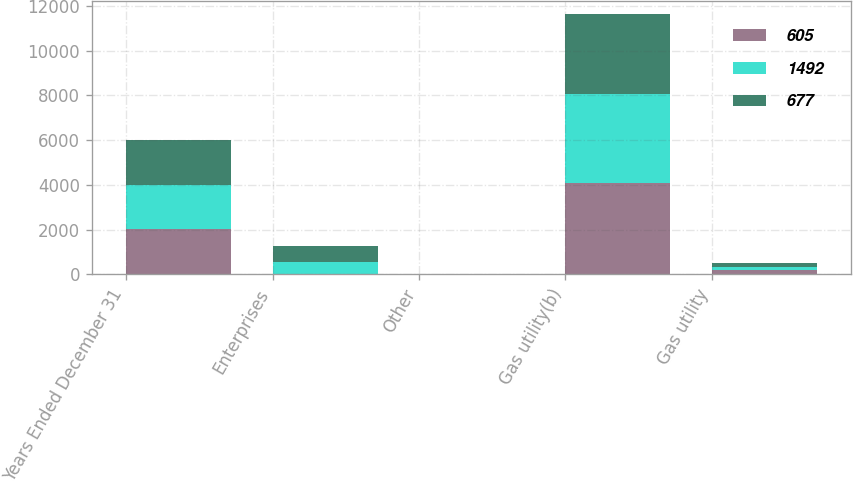<chart> <loc_0><loc_0><loc_500><loc_500><stacked_bar_chart><ecel><fcel>Years Ended December 31<fcel>Enterprises<fcel>Other<fcel>Gas utility(b)<fcel>Gas utility<nl><fcel>605<fcel>2007<fcel>6<fcel>5<fcel>4102<fcel>168<nl><fcel>1492<fcel>2006<fcel>556<fcel>10<fcel>3950<fcel>172<nl><fcel>677<fcel>2005<fcel>698<fcel>13<fcel>3609<fcel>168<nl></chart> 